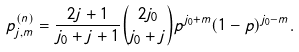<formula> <loc_0><loc_0><loc_500><loc_500>p ^ { ( n ) } _ { j , m } = \frac { 2 j + 1 } { j _ { 0 } + j + 1 } \binom { 2 j _ { 0 } } { j _ { 0 } + j } p ^ { j _ { 0 } + m } ( 1 - p ) ^ { j _ { 0 } - m } .</formula> 